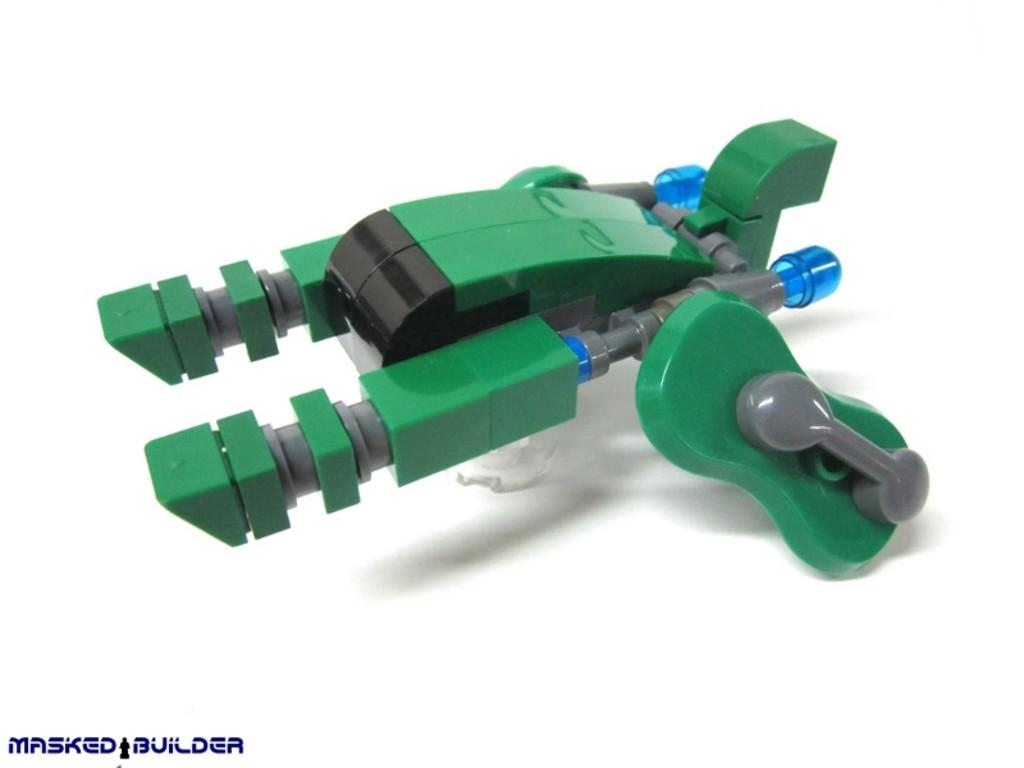What object can be seen in the image? There is a toy in the image. What color is the toy? The toy is green in color. What type of toy is it? The toy appears to be a machine. Is there any text present in the image? Yes, there is text at the bottom of the image. Can you tell me how many sheep are visible in the image? There are no sheep present in the image; it features a green toy that appears to be a machine. What role does the actor play in the image? There is no actor present in the image; it only contains a toy and text. 